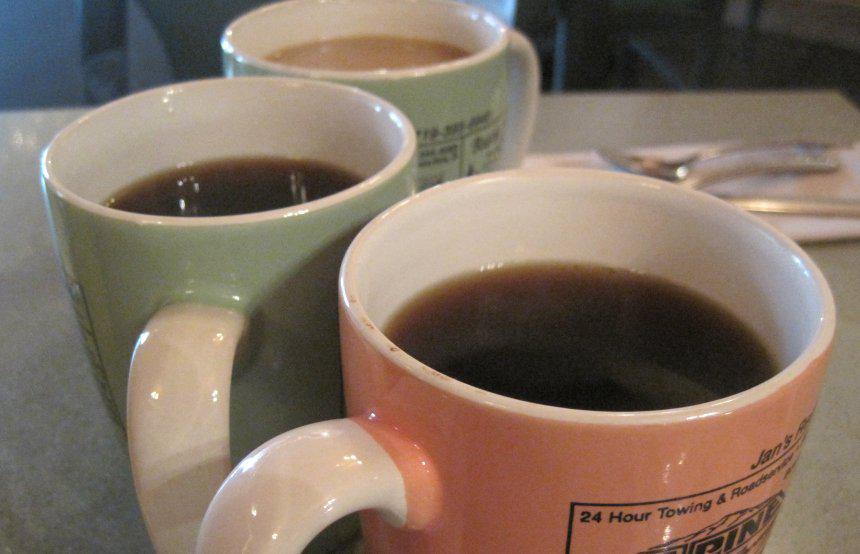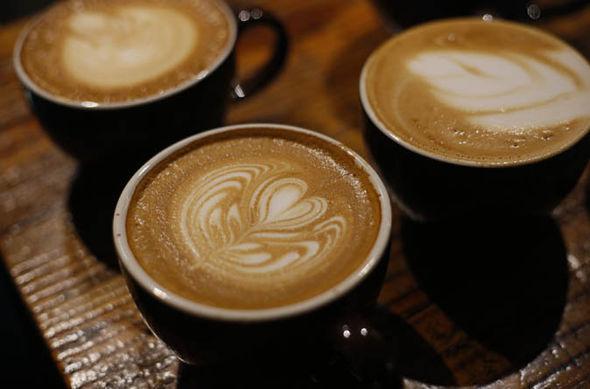The first image is the image on the left, the second image is the image on the right. For the images shown, is this caption "There are at least three coffee cups in the left image." true? Answer yes or no. Yes. The first image is the image on the left, the second image is the image on the right. Considering the images on both sides, is "There are three mugs filled with a cafe drink in the image on the left." valid? Answer yes or no. Yes. 